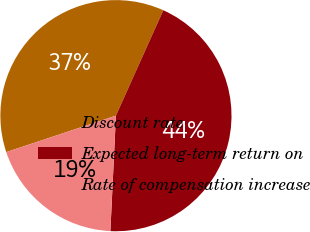<chart> <loc_0><loc_0><loc_500><loc_500><pie_chart><fcel>Discount rate<fcel>Expected long-term return on<fcel>Rate of compensation increase<nl><fcel>36.83%<fcel>44.04%<fcel>19.13%<nl></chart> 